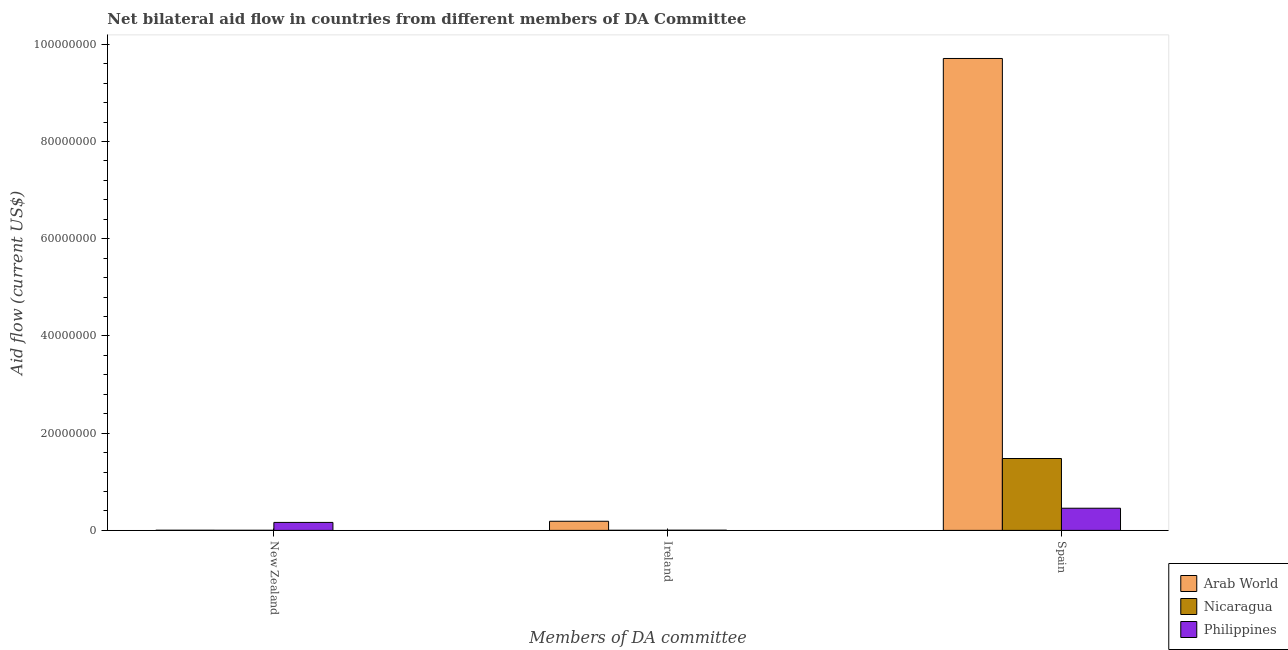How many bars are there on the 3rd tick from the right?
Give a very brief answer. 3. What is the label of the 1st group of bars from the left?
Give a very brief answer. New Zealand. What is the amount of aid provided by ireland in Philippines?
Your answer should be compact. 4.00e+04. Across all countries, what is the maximum amount of aid provided by ireland?
Provide a short and direct response. 1.88e+06. Across all countries, what is the minimum amount of aid provided by ireland?
Provide a succinct answer. 2.00e+04. In which country was the amount of aid provided by new zealand maximum?
Make the answer very short. Philippines. In which country was the amount of aid provided by ireland minimum?
Provide a succinct answer. Nicaragua. What is the total amount of aid provided by ireland in the graph?
Provide a succinct answer. 1.94e+06. What is the difference between the amount of aid provided by ireland in Nicaragua and that in Philippines?
Your answer should be very brief. -2.00e+04. What is the difference between the amount of aid provided by ireland in Philippines and the amount of aid provided by new zealand in Arab World?
Your response must be concise. 10000. What is the average amount of aid provided by ireland per country?
Your answer should be compact. 6.47e+05. What is the difference between the amount of aid provided by new zealand and amount of aid provided by spain in Nicaragua?
Keep it short and to the point. -1.48e+07. Is the amount of aid provided by spain in Nicaragua less than that in Philippines?
Ensure brevity in your answer.  No. Is the difference between the amount of aid provided by ireland in Nicaragua and Arab World greater than the difference between the amount of aid provided by new zealand in Nicaragua and Arab World?
Your answer should be very brief. No. What is the difference between the highest and the second highest amount of aid provided by ireland?
Give a very brief answer. 1.84e+06. What is the difference between the highest and the lowest amount of aid provided by ireland?
Offer a terse response. 1.86e+06. In how many countries, is the amount of aid provided by spain greater than the average amount of aid provided by spain taken over all countries?
Provide a succinct answer. 1. Is the sum of the amount of aid provided by ireland in Philippines and Nicaragua greater than the maximum amount of aid provided by spain across all countries?
Keep it short and to the point. No. What does the 1st bar from the left in Ireland represents?
Your answer should be very brief. Arab World. Is it the case that in every country, the sum of the amount of aid provided by new zealand and amount of aid provided by ireland is greater than the amount of aid provided by spain?
Provide a succinct answer. No. Are all the bars in the graph horizontal?
Provide a short and direct response. No. What is the difference between two consecutive major ticks on the Y-axis?
Offer a very short reply. 2.00e+07. Does the graph contain any zero values?
Your answer should be very brief. No. How many legend labels are there?
Your answer should be compact. 3. What is the title of the graph?
Your response must be concise. Net bilateral aid flow in countries from different members of DA Committee. Does "Greece" appear as one of the legend labels in the graph?
Offer a very short reply. No. What is the label or title of the X-axis?
Offer a very short reply. Members of DA committee. What is the label or title of the Y-axis?
Your response must be concise. Aid flow (current US$). What is the Aid flow (current US$) in Arab World in New Zealand?
Offer a terse response. 3.00e+04. What is the Aid flow (current US$) in Philippines in New Zealand?
Offer a terse response. 1.64e+06. What is the Aid flow (current US$) of Arab World in Ireland?
Ensure brevity in your answer.  1.88e+06. What is the Aid flow (current US$) of Philippines in Ireland?
Ensure brevity in your answer.  4.00e+04. What is the Aid flow (current US$) in Arab World in Spain?
Your answer should be compact. 9.71e+07. What is the Aid flow (current US$) of Nicaragua in Spain?
Provide a succinct answer. 1.48e+07. What is the Aid flow (current US$) of Philippines in Spain?
Keep it short and to the point. 4.56e+06. Across all Members of DA committee, what is the maximum Aid flow (current US$) in Arab World?
Ensure brevity in your answer.  9.71e+07. Across all Members of DA committee, what is the maximum Aid flow (current US$) in Nicaragua?
Give a very brief answer. 1.48e+07. Across all Members of DA committee, what is the maximum Aid flow (current US$) of Philippines?
Your answer should be very brief. 4.56e+06. Across all Members of DA committee, what is the minimum Aid flow (current US$) of Arab World?
Offer a terse response. 3.00e+04. Across all Members of DA committee, what is the minimum Aid flow (current US$) in Nicaragua?
Provide a succinct answer. 2.00e+04. Across all Members of DA committee, what is the minimum Aid flow (current US$) in Philippines?
Your answer should be compact. 4.00e+04. What is the total Aid flow (current US$) in Arab World in the graph?
Provide a short and direct response. 9.90e+07. What is the total Aid flow (current US$) in Nicaragua in the graph?
Offer a terse response. 1.48e+07. What is the total Aid flow (current US$) of Philippines in the graph?
Your response must be concise. 6.24e+06. What is the difference between the Aid flow (current US$) of Arab World in New Zealand and that in Ireland?
Offer a terse response. -1.85e+06. What is the difference between the Aid flow (current US$) in Nicaragua in New Zealand and that in Ireland?
Offer a terse response. 0. What is the difference between the Aid flow (current US$) of Philippines in New Zealand and that in Ireland?
Offer a very short reply. 1.60e+06. What is the difference between the Aid flow (current US$) of Arab World in New Zealand and that in Spain?
Ensure brevity in your answer.  -9.71e+07. What is the difference between the Aid flow (current US$) in Nicaragua in New Zealand and that in Spain?
Make the answer very short. -1.48e+07. What is the difference between the Aid flow (current US$) in Philippines in New Zealand and that in Spain?
Provide a succinct answer. -2.92e+06. What is the difference between the Aid flow (current US$) in Arab World in Ireland and that in Spain?
Give a very brief answer. -9.52e+07. What is the difference between the Aid flow (current US$) in Nicaragua in Ireland and that in Spain?
Offer a very short reply. -1.48e+07. What is the difference between the Aid flow (current US$) of Philippines in Ireland and that in Spain?
Provide a short and direct response. -4.52e+06. What is the difference between the Aid flow (current US$) in Arab World in New Zealand and the Aid flow (current US$) in Nicaragua in Ireland?
Offer a terse response. 10000. What is the difference between the Aid flow (current US$) in Arab World in New Zealand and the Aid flow (current US$) in Philippines in Ireland?
Make the answer very short. -10000. What is the difference between the Aid flow (current US$) of Nicaragua in New Zealand and the Aid flow (current US$) of Philippines in Ireland?
Keep it short and to the point. -2.00e+04. What is the difference between the Aid flow (current US$) in Arab World in New Zealand and the Aid flow (current US$) in Nicaragua in Spain?
Your answer should be very brief. -1.48e+07. What is the difference between the Aid flow (current US$) of Arab World in New Zealand and the Aid flow (current US$) of Philippines in Spain?
Offer a very short reply. -4.53e+06. What is the difference between the Aid flow (current US$) in Nicaragua in New Zealand and the Aid flow (current US$) in Philippines in Spain?
Provide a succinct answer. -4.54e+06. What is the difference between the Aid flow (current US$) of Arab World in Ireland and the Aid flow (current US$) of Nicaragua in Spain?
Make the answer very short. -1.29e+07. What is the difference between the Aid flow (current US$) in Arab World in Ireland and the Aid flow (current US$) in Philippines in Spain?
Ensure brevity in your answer.  -2.68e+06. What is the difference between the Aid flow (current US$) in Nicaragua in Ireland and the Aid flow (current US$) in Philippines in Spain?
Your response must be concise. -4.54e+06. What is the average Aid flow (current US$) in Arab World per Members of DA committee?
Provide a succinct answer. 3.30e+07. What is the average Aid flow (current US$) of Nicaragua per Members of DA committee?
Provide a succinct answer. 4.94e+06. What is the average Aid flow (current US$) in Philippines per Members of DA committee?
Your response must be concise. 2.08e+06. What is the difference between the Aid flow (current US$) of Arab World and Aid flow (current US$) of Philippines in New Zealand?
Ensure brevity in your answer.  -1.61e+06. What is the difference between the Aid flow (current US$) of Nicaragua and Aid flow (current US$) of Philippines in New Zealand?
Your answer should be very brief. -1.62e+06. What is the difference between the Aid flow (current US$) of Arab World and Aid flow (current US$) of Nicaragua in Ireland?
Your answer should be compact. 1.86e+06. What is the difference between the Aid flow (current US$) of Arab World and Aid flow (current US$) of Philippines in Ireland?
Offer a terse response. 1.84e+06. What is the difference between the Aid flow (current US$) of Nicaragua and Aid flow (current US$) of Philippines in Ireland?
Ensure brevity in your answer.  -2.00e+04. What is the difference between the Aid flow (current US$) in Arab World and Aid flow (current US$) in Nicaragua in Spain?
Give a very brief answer. 8.23e+07. What is the difference between the Aid flow (current US$) of Arab World and Aid flow (current US$) of Philippines in Spain?
Keep it short and to the point. 9.25e+07. What is the difference between the Aid flow (current US$) of Nicaragua and Aid flow (current US$) of Philippines in Spain?
Ensure brevity in your answer.  1.02e+07. What is the ratio of the Aid flow (current US$) in Arab World in New Zealand to that in Ireland?
Offer a terse response. 0.02. What is the ratio of the Aid flow (current US$) of Nicaragua in New Zealand to that in Spain?
Make the answer very short. 0. What is the ratio of the Aid flow (current US$) in Philippines in New Zealand to that in Spain?
Make the answer very short. 0.36. What is the ratio of the Aid flow (current US$) in Arab World in Ireland to that in Spain?
Keep it short and to the point. 0.02. What is the ratio of the Aid flow (current US$) of Nicaragua in Ireland to that in Spain?
Give a very brief answer. 0. What is the ratio of the Aid flow (current US$) in Philippines in Ireland to that in Spain?
Keep it short and to the point. 0.01. What is the difference between the highest and the second highest Aid flow (current US$) of Arab World?
Give a very brief answer. 9.52e+07. What is the difference between the highest and the second highest Aid flow (current US$) of Nicaragua?
Offer a very short reply. 1.48e+07. What is the difference between the highest and the second highest Aid flow (current US$) in Philippines?
Provide a short and direct response. 2.92e+06. What is the difference between the highest and the lowest Aid flow (current US$) in Arab World?
Offer a very short reply. 9.71e+07. What is the difference between the highest and the lowest Aid flow (current US$) in Nicaragua?
Your answer should be compact. 1.48e+07. What is the difference between the highest and the lowest Aid flow (current US$) of Philippines?
Give a very brief answer. 4.52e+06. 